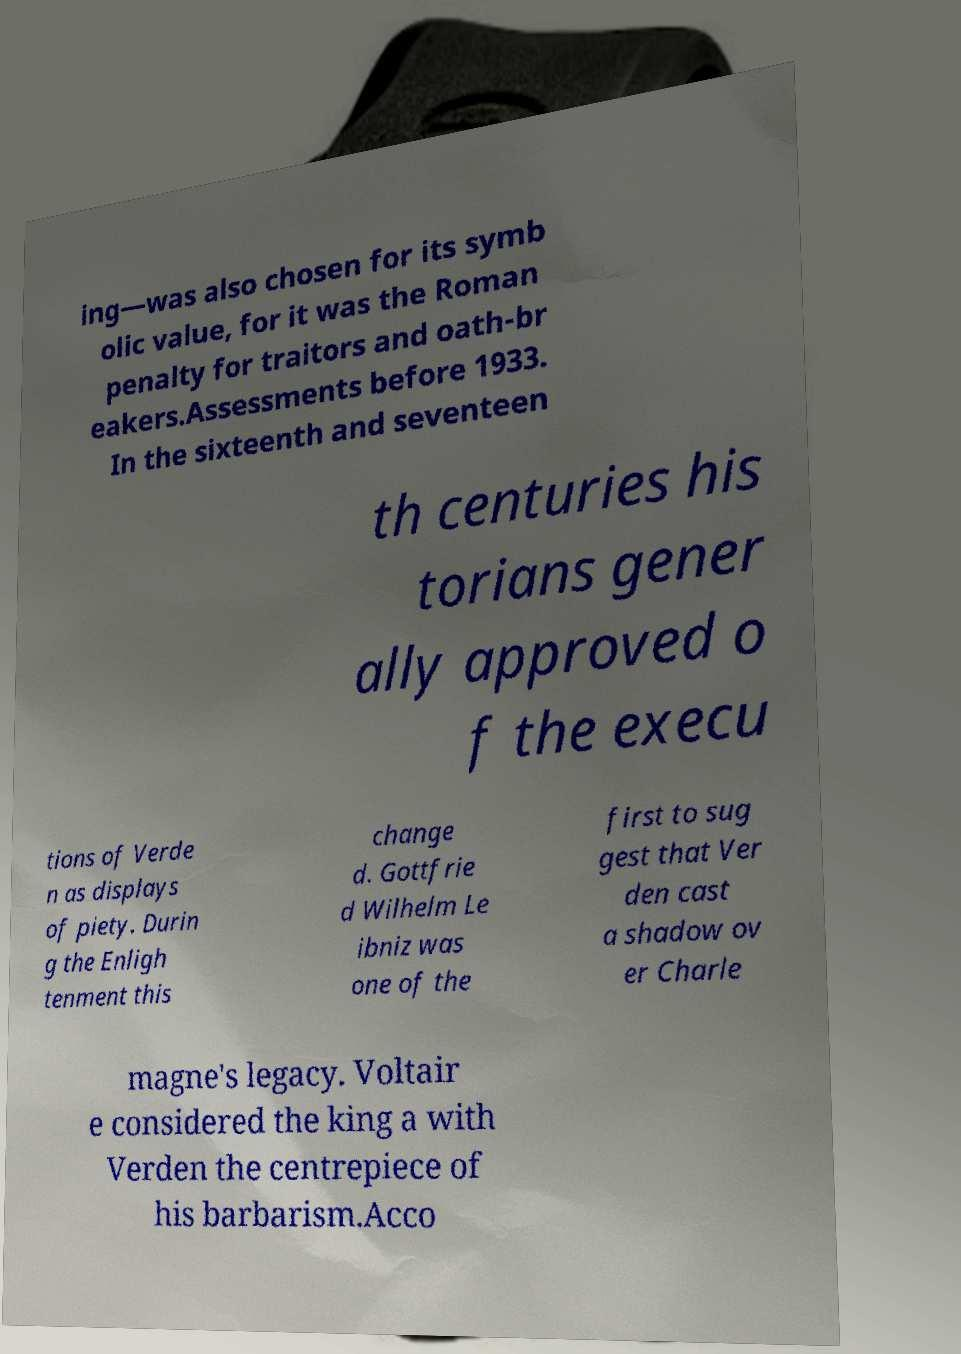Can you accurately transcribe the text from the provided image for me? ing—was also chosen for its symb olic value, for it was the Roman penalty for traitors and oath-br eakers.Assessments before 1933. In the sixteenth and seventeen th centuries his torians gener ally approved o f the execu tions of Verde n as displays of piety. Durin g the Enligh tenment this change d. Gottfrie d Wilhelm Le ibniz was one of the first to sug gest that Ver den cast a shadow ov er Charle magne's legacy. Voltair e considered the king a with Verden the centrepiece of his barbarism.Acco 